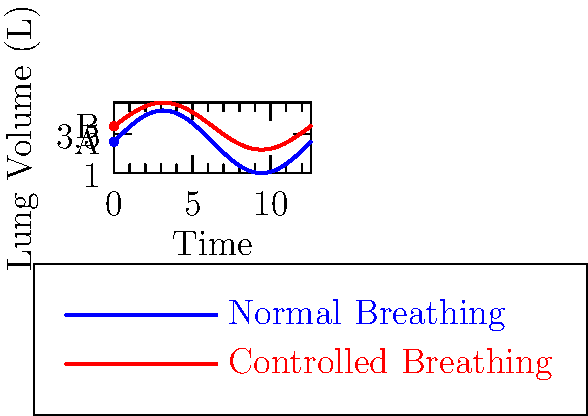The diagram shows lung volume changes during normal breathing (blue) and controlled breathing (red) over time. If a person transitions from point A to point B using a controlled breathing technique, what is the approximate percentage increase in lung volume? To calculate the percentage increase in lung volume, we need to follow these steps:

1. Identify the initial lung volume (point A): 3 L
2. Identify the final lung volume (point B): 4 L
3. Calculate the difference: 4 L - 3 L = 1 L
4. Calculate the percentage increase using the formula:
   $$ \text{Percentage Increase} = \frac{\text{Increase}}{\text{Original Value}} \times 100\% $$
5. Plug in the values:
   $$ \text{Percentage Increase} = \frac{1 \text{ L}}{3 \text{ L}} \times 100\% = 0.3333... \times 100\% \approx 33.33\% $$

Therefore, the approximate percentage increase in lung volume is 33.33%.
Answer: 33.33% 